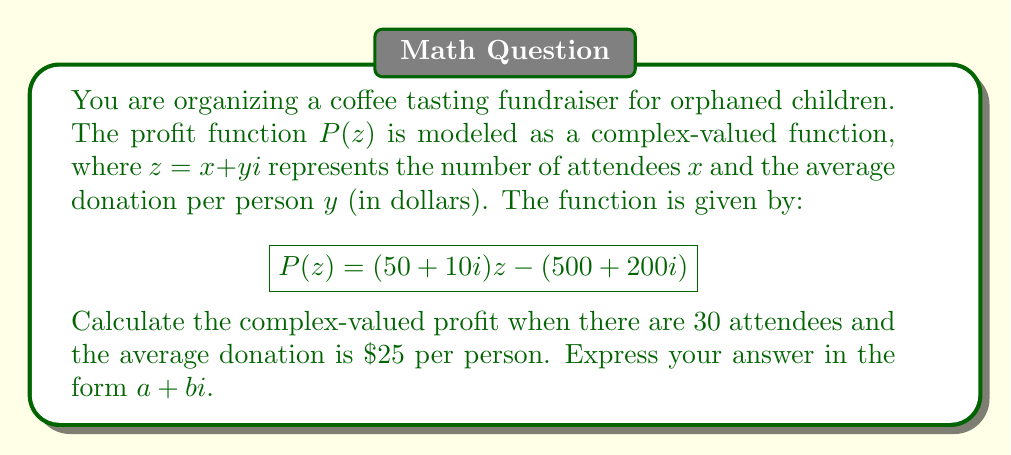Could you help me with this problem? To solve this problem, we need to follow these steps:

1) First, let's identify the values for $x$ and $y$:
   $x = 30$ (number of attendees)
   $y = 25$ (average donation per person in dollars)

2) We can form the complex number $z = x + yi$:
   $z = 30 + 25i$

3) Now, we can substitute this into the given profit function:
   $$P(z) = (50 + 10i)z - (500 + 200i)$$

4) Let's multiply $(50 + 10i)$ by $z$:
   $(50 + 10i)(30 + 25i) = 1500 + 1250i + 300i + 250i^2$
   $= 1500 + 1550i - 250$ (since $i^2 = -1$)
   $= 1250 + 1550i$

5) Now we can complete the calculation:
   $P(z) = (1250 + 1550i) - (500 + 200i)$
   $= (1250 - 500) + (1550i - 200i)$
   $= 750 + 1350i$

Therefore, the complex-valued profit is $750 + 1350i$.
Answer: $750 + 1350i$ 